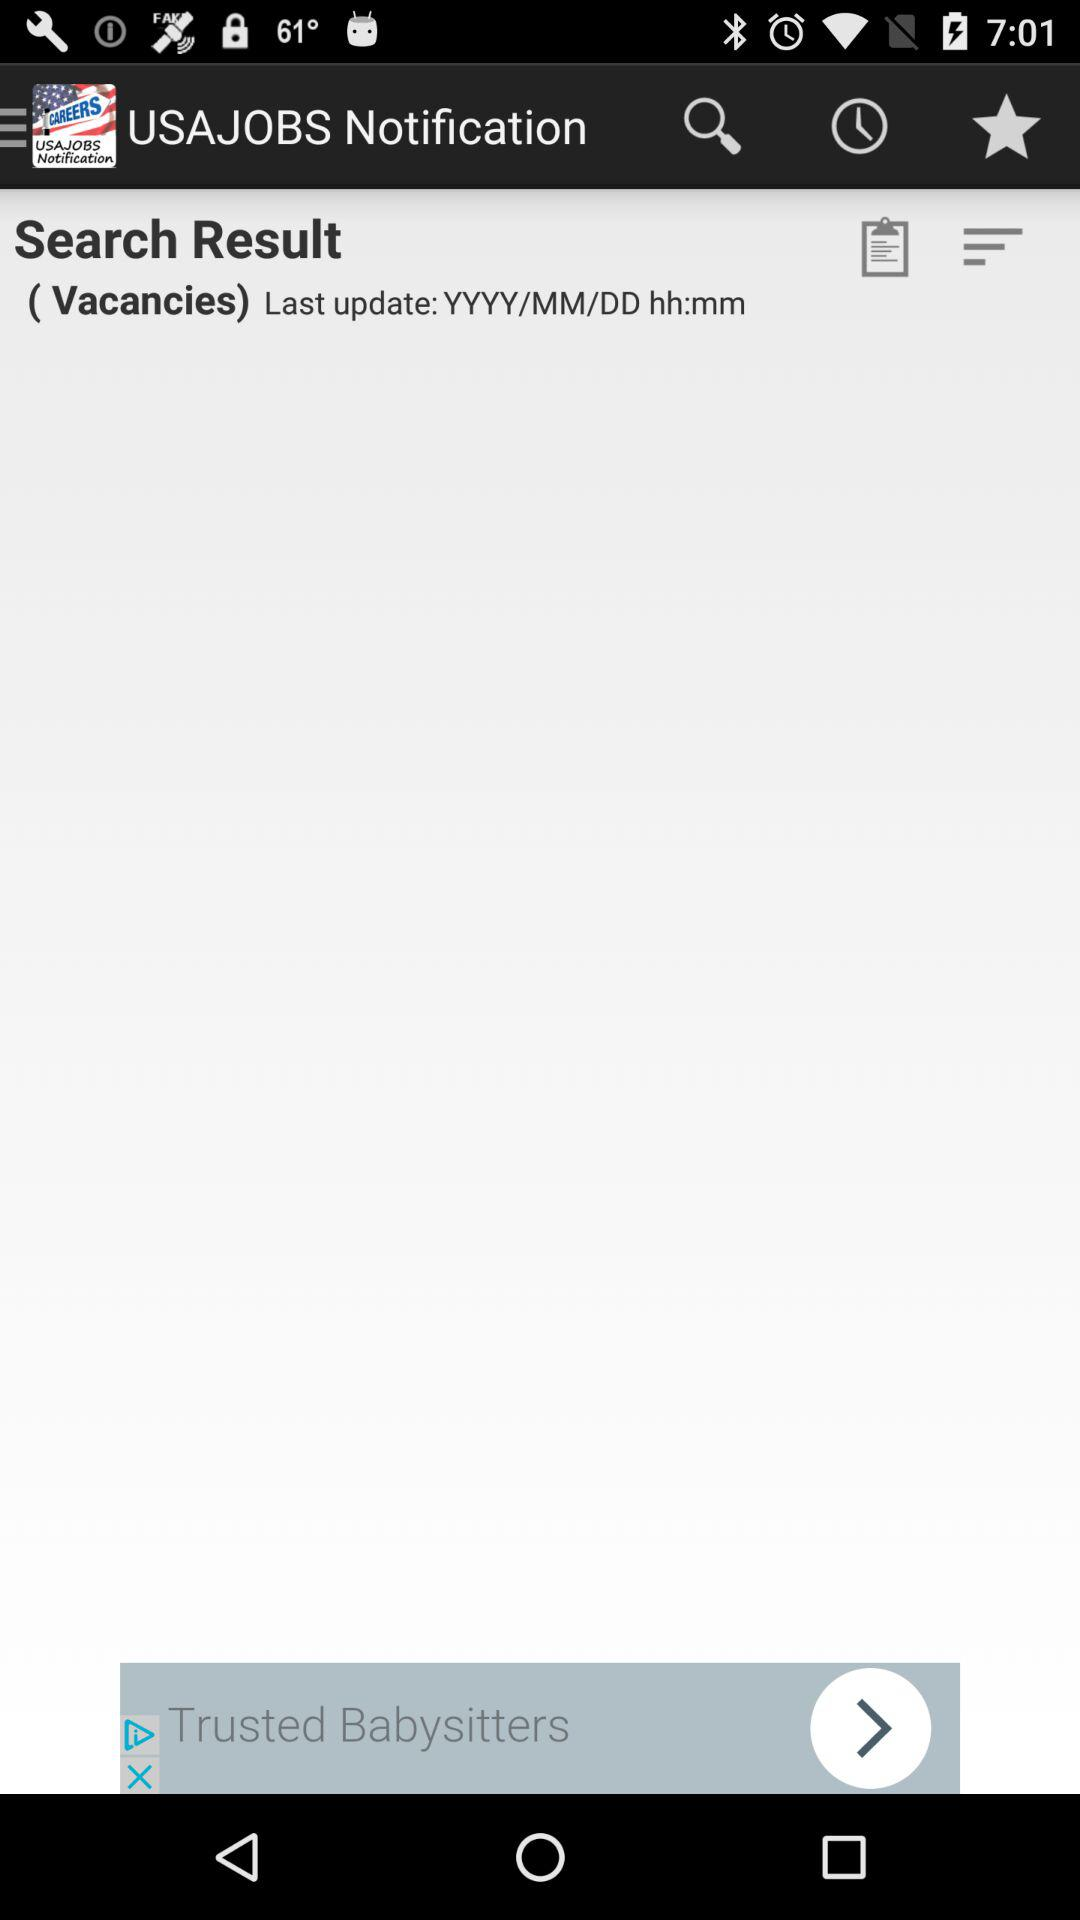What is the name of the application? The name of the application is "USAJOBS Notification". 